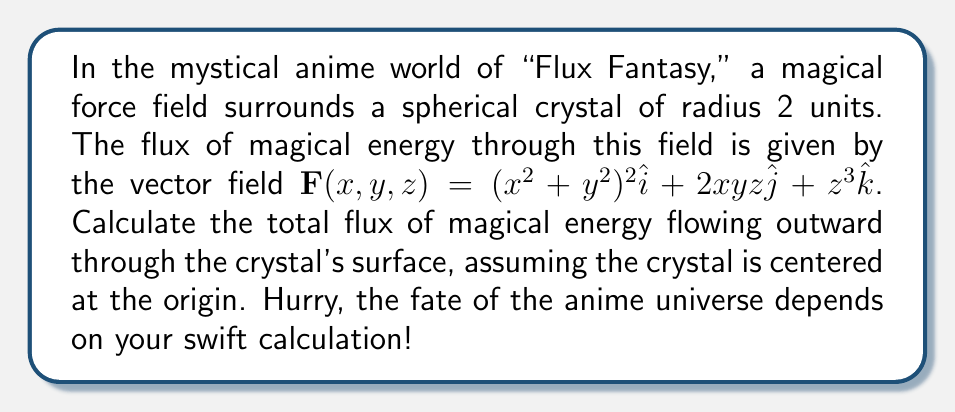Solve this math problem. Let's approach this magical problem step-by-step:

1) We need to use the divergence theorem to solve this problem quickly. The divergence theorem states:

   $$\iiint_V \nabla \cdot \mathbf{F} \, dV = \iint_S \mathbf{F} \cdot \mathbf{n} \, dS$$

   where $S$ is the surface of the sphere and $\mathbf{n}$ is the outward unit normal vector.

2) First, let's calculate the divergence of $\mathbf{F}$:

   $$\nabla \cdot \mathbf{F} = \frac{\partial}{\partial x}((x^2+y^2)^2) + \frac{\partial}{\partial y}(2xyz) + \frac{\partial}{\partial z}(z^3)$$

3) Simplifying:

   $$\nabla \cdot \mathbf{F} = 4(x^2+y^2)(2x) + 2xy + 3z^2 = 8x^3 + 8xy^2 + 2xy + 3z^2$$

4) Now, we need to integrate this over the volume of the sphere. In spherical coordinates:

   $$\iiint_V \nabla \cdot \mathbf{F} \, dV = \int_0^{2\pi} \int_0^{\pi} \int_0^2 (8r^3\cos^3\theta\sin^3\phi + 8r^3\cos\theta\sin^3\theta\sin^3\phi + 2r^2\cos\theta\sin\theta\sin^2\phi + 3r^2\cos^2\phi) r^2\sin\phi \, dr \, d\phi \, d\theta$$

5) This integral is complex, but we can simplify it using the symmetry of the sphere. The terms with odd powers of $\cos\theta$ or $\sin\theta$ will integrate to zero over $[0,2\pi]$. So, we're left with:

   $$\iiint_V \nabla \cdot \mathbf{F} \, dV = \int_0^{2\pi} \int_0^{\pi} \int_0^2 3r^4\cos^2\phi\sin\phi \, dr \, d\phi \, d\theta$$

6) Evaluating the integrals:

   $$= 2\pi \cdot \int_0^{\pi} \int_0^2 3r^4\cos^2\phi\sin\phi \, dr \, d\phi$$
   $$= 2\pi \cdot \frac{3}{5} \cdot 2^5 \cdot \int_0^{\pi} \cos^2\phi\sin\phi \, d\phi$$
   $$= \frac{192\pi}{5} \cdot \frac{1}{3} = \frac{64\pi}{5}$$

Therefore, the total flux of magical energy flowing outward through the crystal's surface is $\frac{64\pi}{5}$ units.
Answer: $\frac{64\pi}{5}$ 